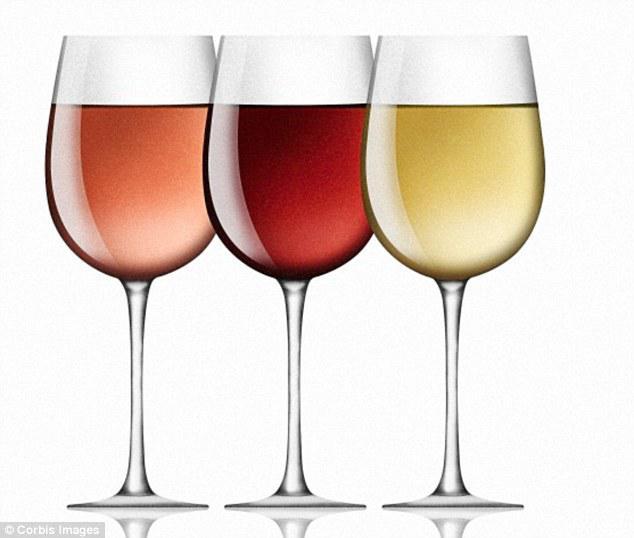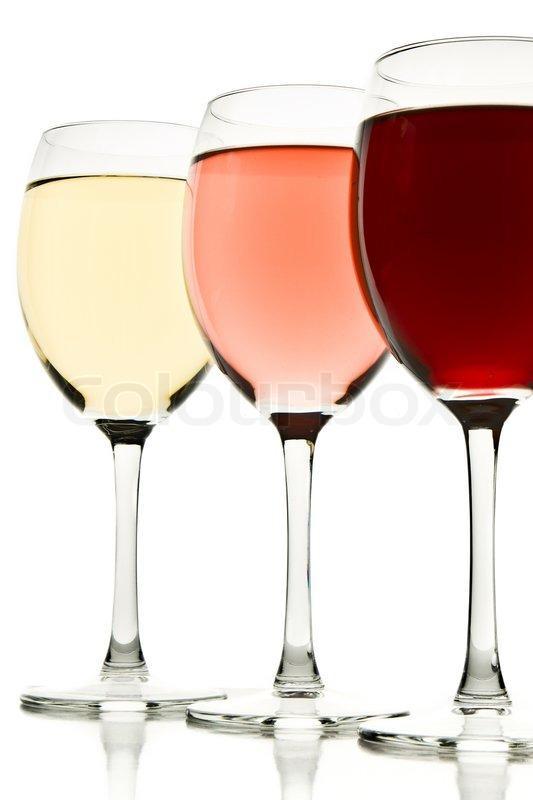The first image is the image on the left, the second image is the image on the right. Examine the images to the left and right. Is the description "The wine glass furthest to the right in the right image contains dark red liquid." accurate? Answer yes or no. Yes. The first image is the image on the left, the second image is the image on the right. Given the left and right images, does the statement "Each image shows exactly three wine glasses, which contain different colors of wine." hold true? Answer yes or no. Yes. 